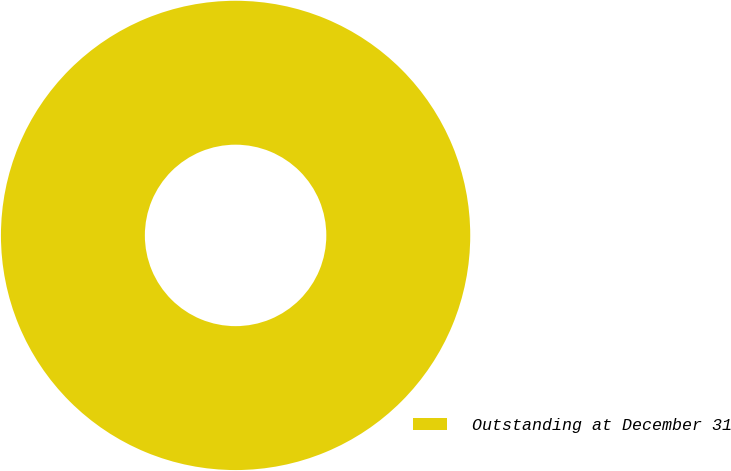Convert chart. <chart><loc_0><loc_0><loc_500><loc_500><pie_chart><fcel>Outstanding at December 31<nl><fcel>100.0%<nl></chart> 